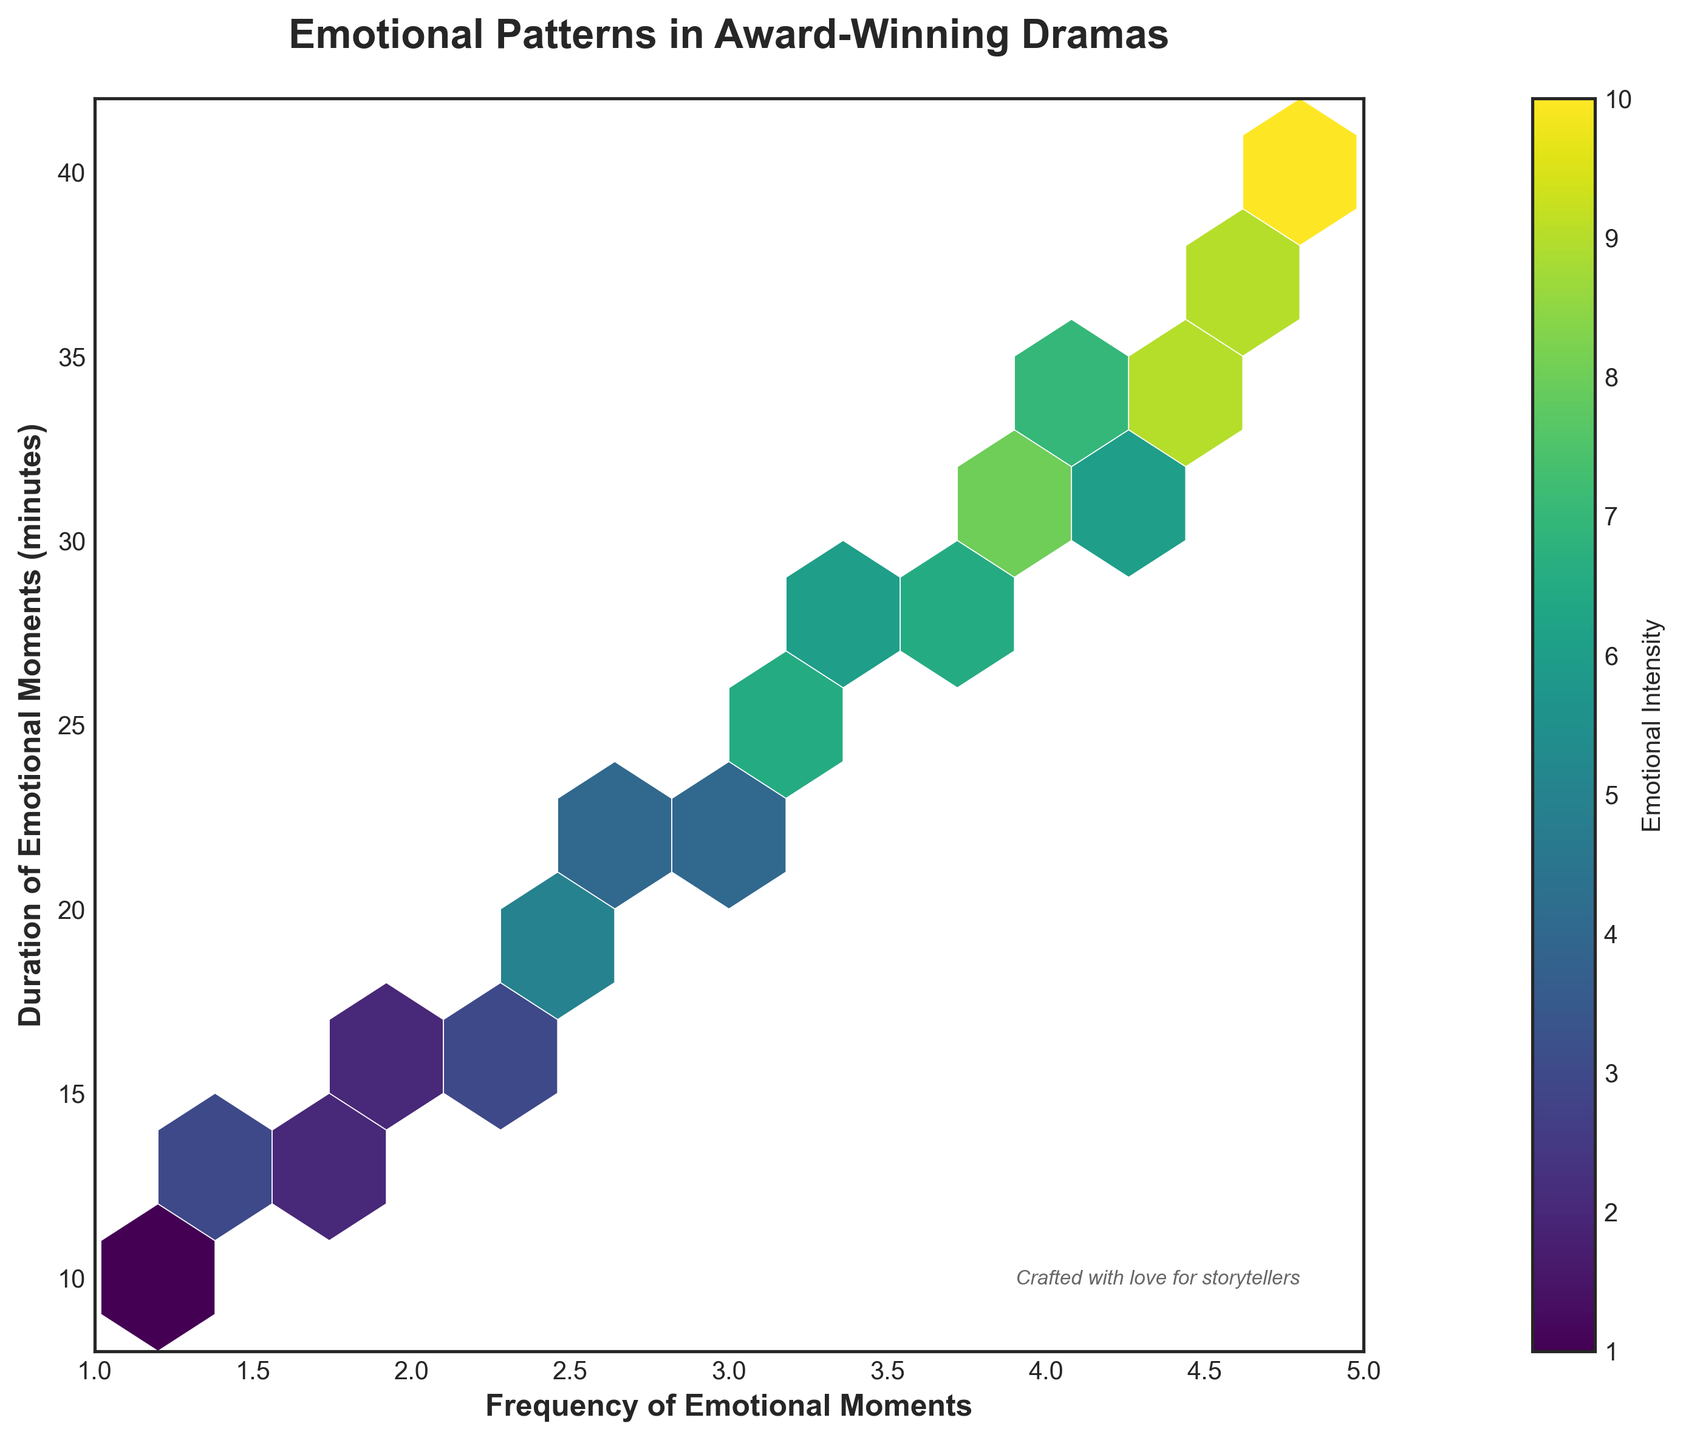what is the title of the plot? The title of the plot is centered at the top of the figure, written in a bold and prominent font.
Answer: Emotional Patterns in Award-Winning Dramas what’s the range of the x-axis? To find the range of the x-axis, look at the two limits marked on the axis; the plot sets x-axis labels from 1 to 5.
Answer: 1 to 5 what does the color bar represent? The color bar displayed on the right side of the plot uses different colors to represent varying levels of emotional intensity.
Answer: Emotional Intensity what’s the highest frequency of emotional moments shown? Identify the highest x-axis value on the plot, which goes up to 4.8, indicating the highest frequency of emotional moments.
Answer: 4.8 which area shows the highest emotional intensity? The color bar indicates that the darkest color signifies the highest emotional intensity. The darkest hexagon appears around the (4.8, 40) coordinate.
Answer: Around (4.8, 40) what are the axes labels? Examine the labels on both axes; the x-axis label is "Frequency of Emotional Moments" and the y-axis label is "Duration of Emotional Moments (minutes)."
Answer: x-axis: Frequency of Emotional Moments; y-axis: Duration of Emotional Moments (minutes) what’s the correlation between frequency and duration of emotional moments? Look for the trend in the hexagon placements. Generally, as the frequency increases (moves right on the x-axis), the duration of emotional moments also increases (moves up on the y-axis), suggesting a positive correlation.
Answer: Positive correlation which frequency range contains the most variety of emotional intensities? Determine the frequency range with the most differing colors; the hexagons from frequencies 3.1 to 4.8 show varying colors, indicating different emotional intensities.
Answer: 3.1 to 4.8 how do duration and frequency relate at high emotional intensities? Observe the darkest hexagons (high intensities) which are mostly located towards the upper-right area of the plot; this indicates they correspond with high frequencies and longer durations.
Answer: High frequencies and longer durations what’s the message conveyed in the italicized text on the plot? The small italicized text at the bottom right of the plot says, "Crafted with love for storytellers," which appears to be a thoughtful addition to emphasize the purpose of the plot.
Answer: Crafted with love for storytellers 